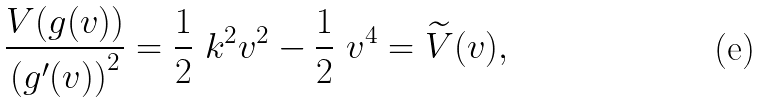Convert formula to latex. <formula><loc_0><loc_0><loc_500><loc_500>\frac { V ( g ( v ) ) } { \left ( g ^ { \prime } ( v ) \right ) ^ { 2 } } = \frac { 1 } { 2 } \ k ^ { 2 } v ^ { 2 } - \frac { 1 } { 2 } \ v ^ { 4 } = \widetilde { V } ( v ) ,</formula> 